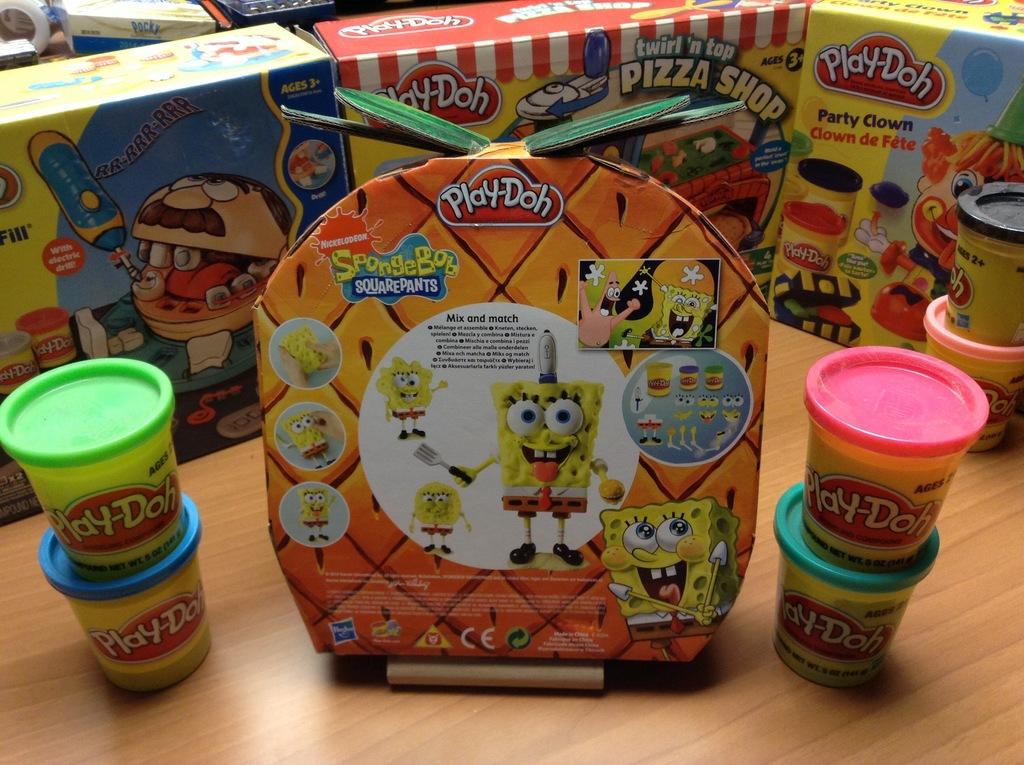What objects are present in the image? There are toys in the image. How are the toys arranged or organized? The toys are placed in boxes. On what surface are the boxes with toys located? The boxes with toys are placed on a wooden table. What type of flight can be seen taking off in the image? There is no flight present in the image; it only features toys in boxes on a wooden table. 